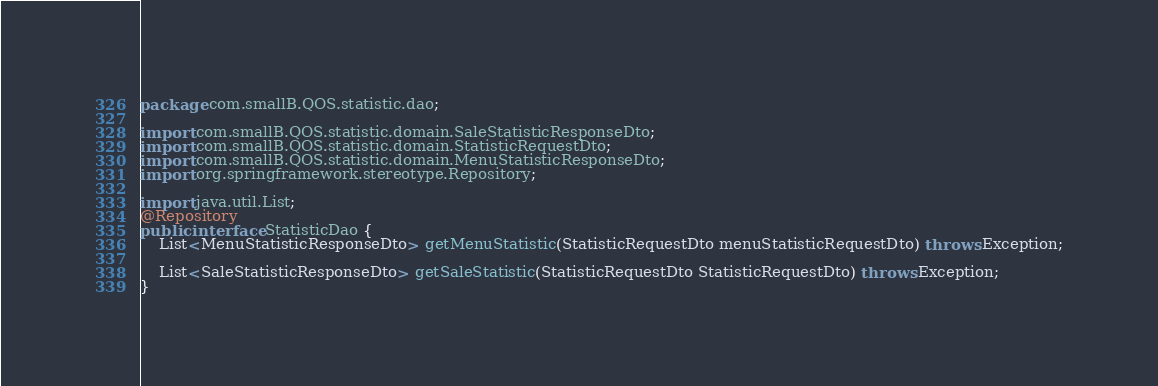<code> <loc_0><loc_0><loc_500><loc_500><_Java_>package com.smallB.QOS.statistic.dao;

import com.smallB.QOS.statistic.domain.SaleStatisticResponseDto;
import com.smallB.QOS.statistic.domain.StatisticRequestDto;
import com.smallB.QOS.statistic.domain.MenuStatisticResponseDto;
import org.springframework.stereotype.Repository;

import java.util.List;
@Repository
public interface StatisticDao {
    List<MenuStatisticResponseDto> getMenuStatistic(StatisticRequestDto menuStatisticRequestDto) throws Exception;

    List<SaleStatisticResponseDto> getSaleStatistic(StatisticRequestDto StatisticRequestDto) throws Exception;
}
</code> 